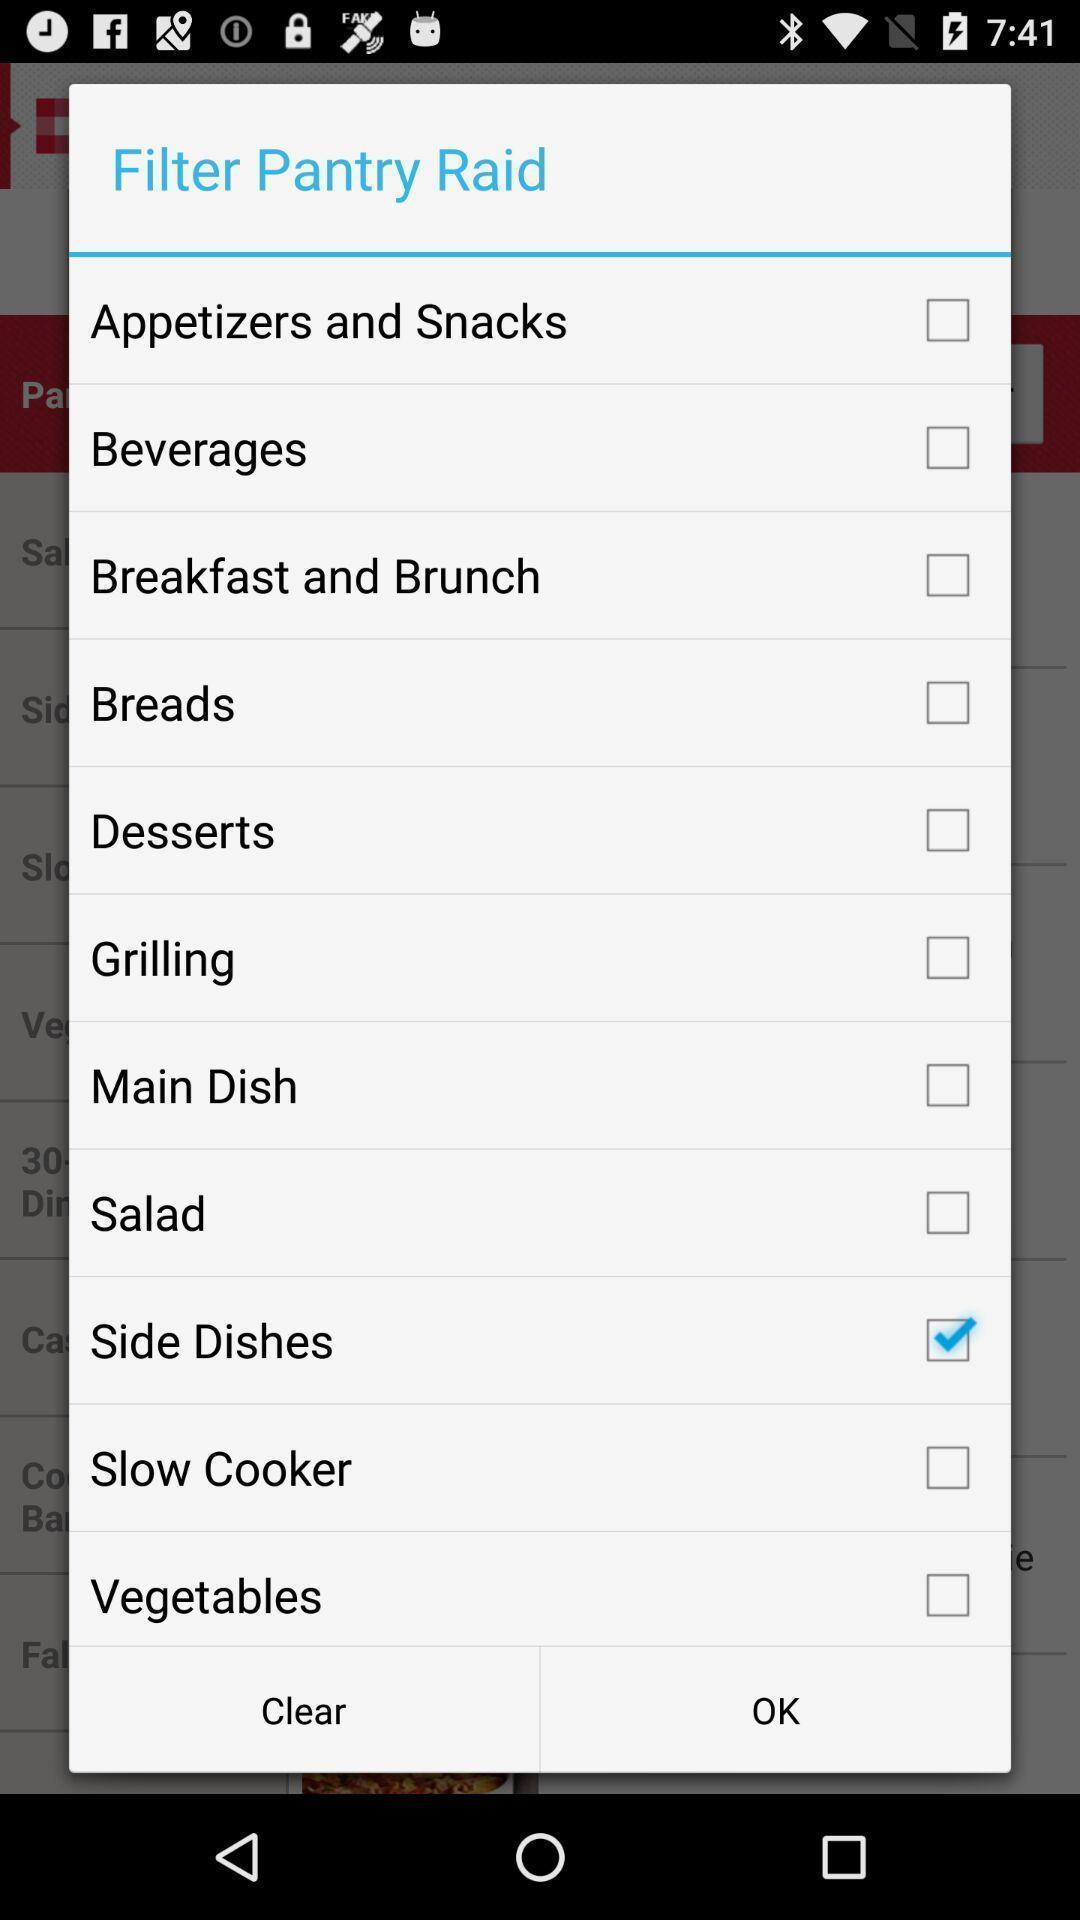Provide a textual representation of this image. Pop-up showing the filter option for the pantry raid. 